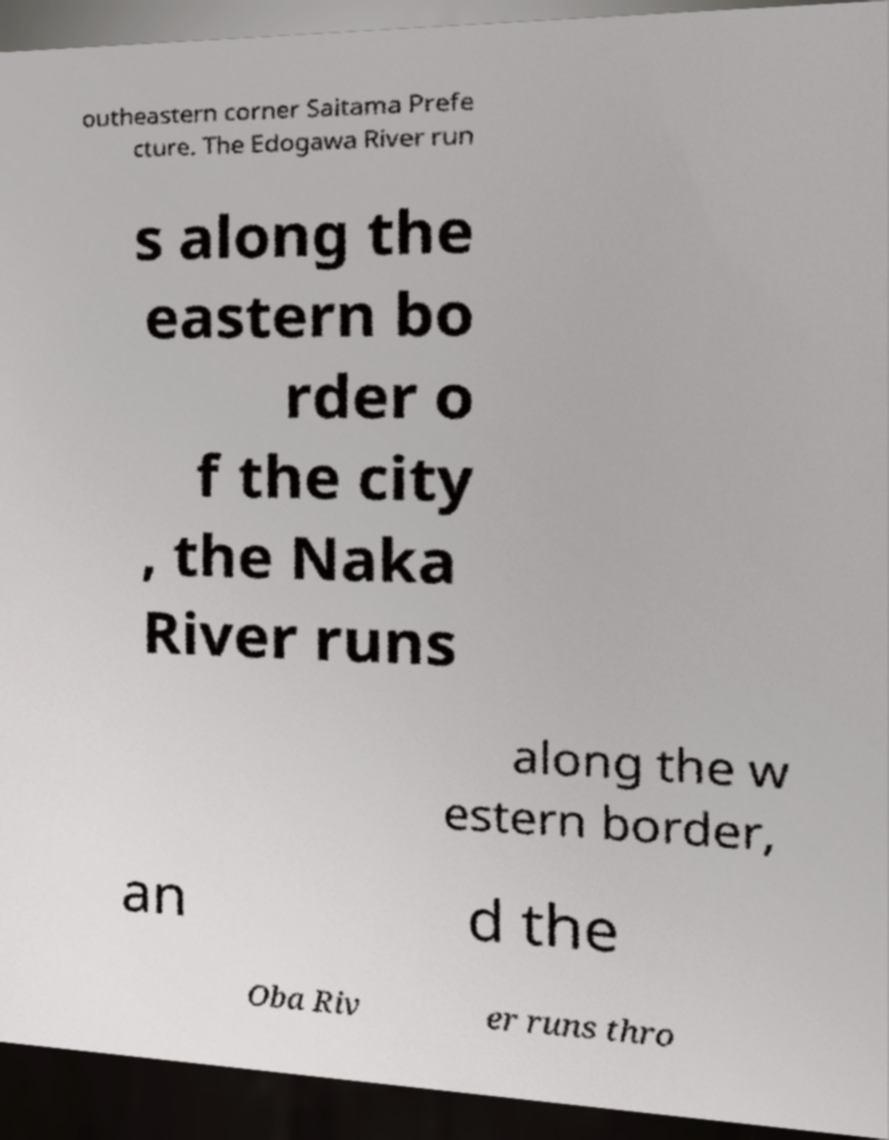I need the written content from this picture converted into text. Can you do that? outheastern corner Saitama Prefe cture. The Edogawa River run s along the eastern bo rder o f the city , the Naka River runs along the w estern border, an d the Oba Riv er runs thro 